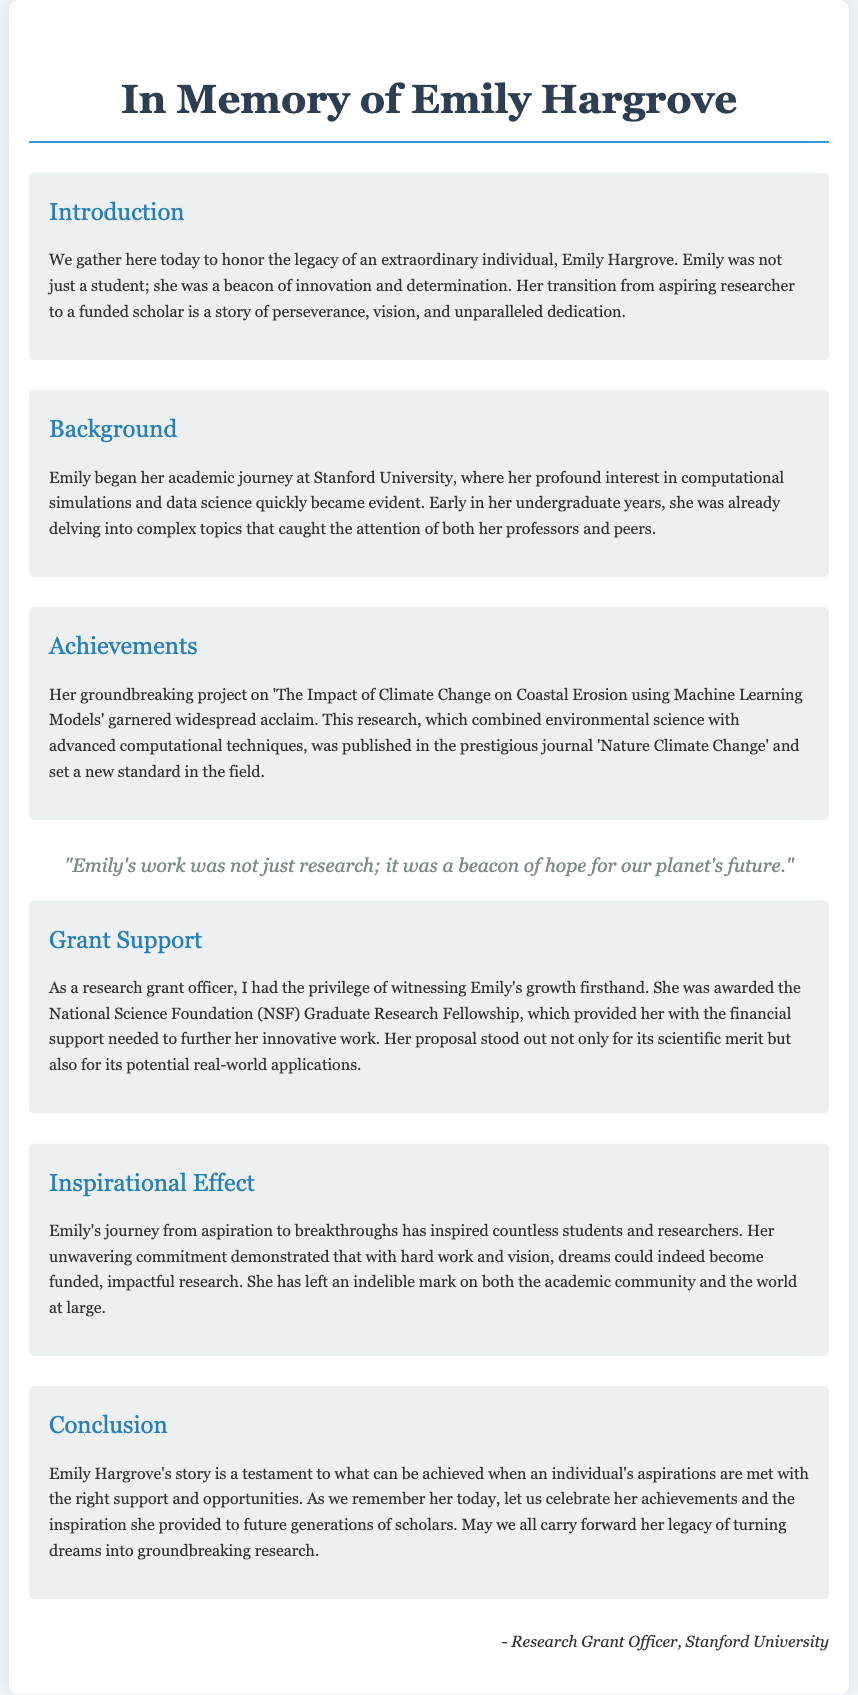What is the name of the student being honored? The document specifically honors Emily Hargrove.
Answer: Emily Hargrove What was the title of Emily's groundbreaking project? The title of her project on climate change is provided in the achievements section.
Answer: The Impact of Climate Change on Coastal Erosion using Machine Learning Models Which prestigious journal published Emily's research? The document mentions the prestigious journal in which her research was published.
Answer: Nature Climate Change What fellowship did Emily receive for her research? The grant support section mentions the specific fellowship awarded to her.
Answer: National Science Foundation Graduate Research Fellowship Where did Emily begin her academic journey? The document states the university where Emily started her studies.
Answer: Stanford University What quality made Emily's research proposal stand out? The document describes the characteristics of her proposal in relation to its recognition.
Answer: Scientific merit and potential real-world applications How has Emily's work impacted future researchers? The inspirational effect section describes the broader influence of Emily's journey.
Answer: Inspired countless students and researchers What is the overall theme of the eulogy? The conclusion highlights the main message conveyed throughout the document.
Answer: Turning dreams into groundbreaking research 